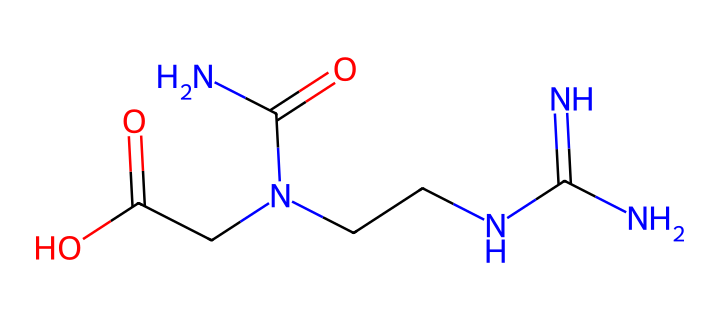What is the molecular formula of creatine? To determine the molecular formula from the SMILES notation, we need to identify the various atoms present. The SMILES shows one nitrogen (N) atom bonded to another nitrogen (N), and two carbon (C) atoms, along with additional components consisting of oxygen (O) and more nitrogen. Counting these, we find there are 4 carbon (C), 9 hydrogen (H), 4 nitrogen (N), and 2 oxygen (O) atoms, leading to the formula C4H9N3O2.
Answer: C4H9N3O2 How many nitrogen atoms are in the molecule? In the provided SMILES notation, we directly observe the "N" characters representing nitrogen atoms. By counting them, we see there are 4 'N' in the sequence, indicating four nitrogen atoms are present.
Answer: 4 What functional groups are present in creatine? Analyzing the SMILES structure, we can identify key functional groups by looking for common groupings; in this case, we see an amine (due to the N atoms) and a carboxylic acid group (evident from (C(=O)O)). Thus, the functional groups present are amine and carboxylic acid.
Answer: amine, carboxylic acid Does this molecule have any double bonds? In the SMILES representation, a double bond is indicated by the '=' sign. Observing the structure, we find a carbon (C) double-bonded to an oxygen (O) atom, resulting in one double bond. Therefore, the molecule contains one double bond.
Answer: 1 Is creatine a polar or nonpolar substance? The presence of polar functional groups, such as the amine and carboxylic acid, affects polarity. The carboxylic group typically increases polarity due to its ability to form hydrogen bonds, leading us to conclude that creatine is a polar molecule.
Answer: polar 